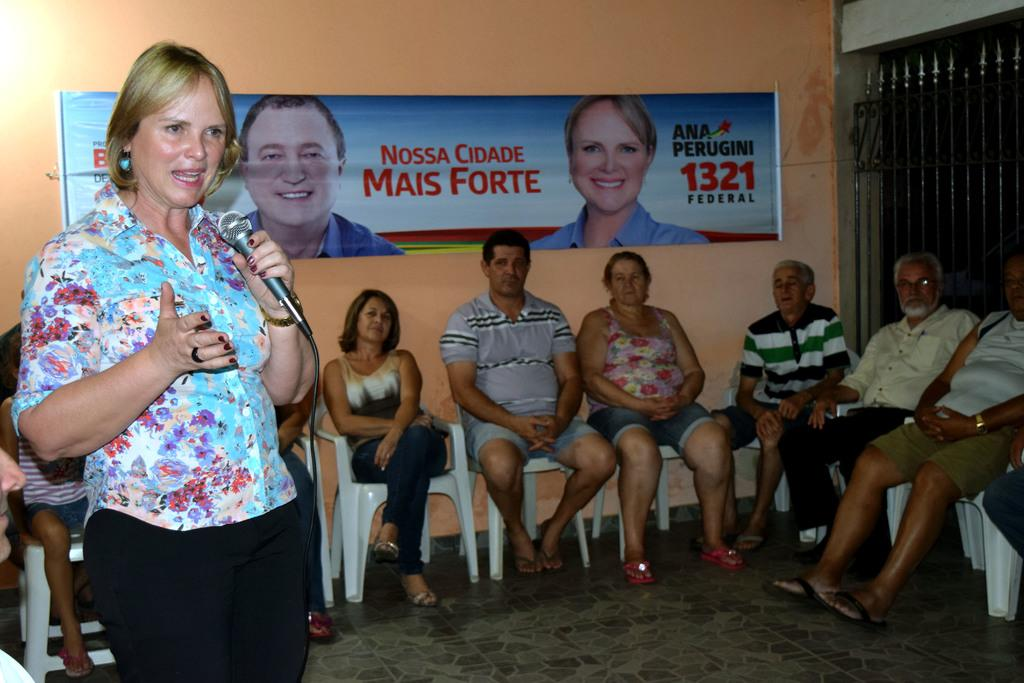What is the lady in the image holding? The lady is holding a mic in the image. Where is the lady located in the image? The lady is on the left side of the image. What are the people in the image doing? The people in the image are sitting. What can be seen in the background of the image? There is a poster and a metal gate in the background of the image. Can you describe the lighting in the image? It appears that there is a light in the top left side of the image. What type of farm animals can be seen in the image? There are no farm animals present in the image. What government policy is being discussed in the image? There is no indication of a government policy being discussed in the image. 